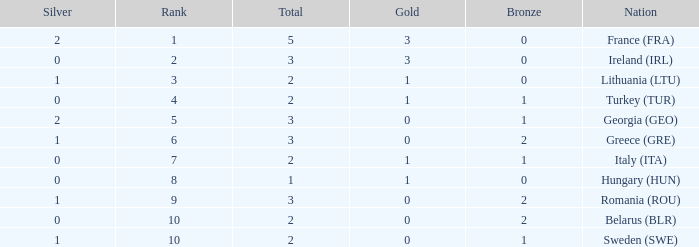What's the total number of bronze medals for Sweden (SWE) having less than 1 gold and silver? 0.0. 